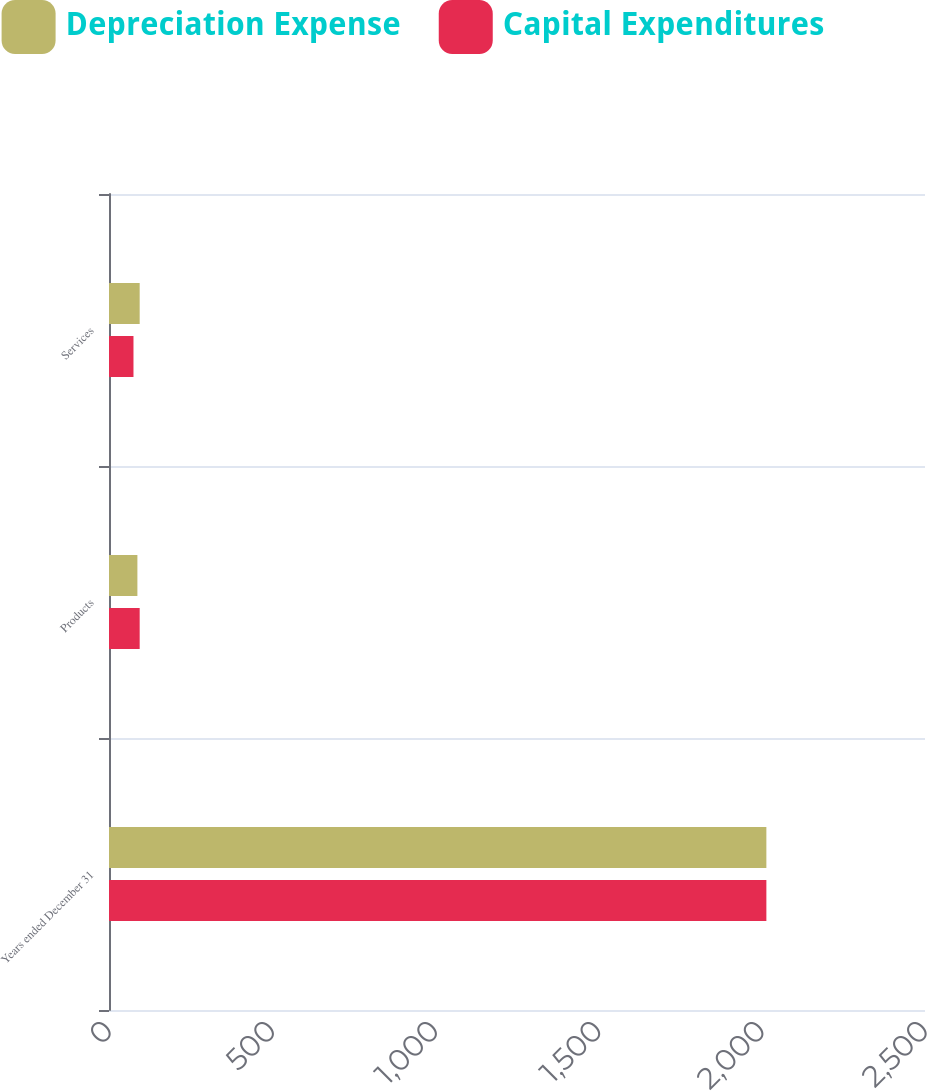Convert chart to OTSL. <chart><loc_0><loc_0><loc_500><loc_500><stacked_bar_chart><ecel><fcel>Years ended December 31<fcel>Products<fcel>Services<nl><fcel>Depreciation Expense<fcel>2014<fcel>87<fcel>94<nl><fcel>Capital Expenditures<fcel>2014<fcel>94<fcel>75<nl></chart> 